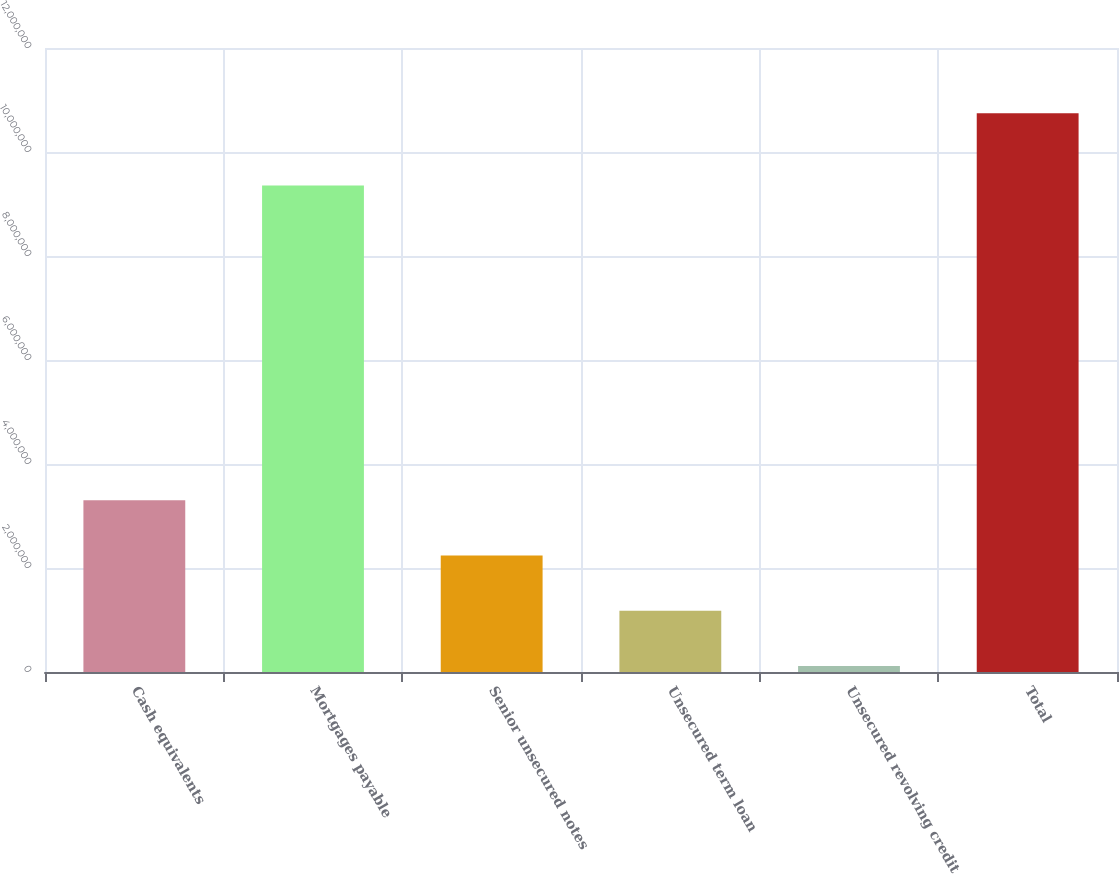<chart> <loc_0><loc_0><loc_500><loc_500><bar_chart><fcel>Cash equivalents<fcel>Mortgages payable<fcel>Senior unsecured notes<fcel>Unsecured term loan<fcel>Unsecured revolving credit<fcel>Total<nl><fcel>3.305e+06<fcel>9.356e+06<fcel>2.242e+06<fcel>1.179e+06<fcel>116000<fcel>1.0746e+07<nl></chart> 